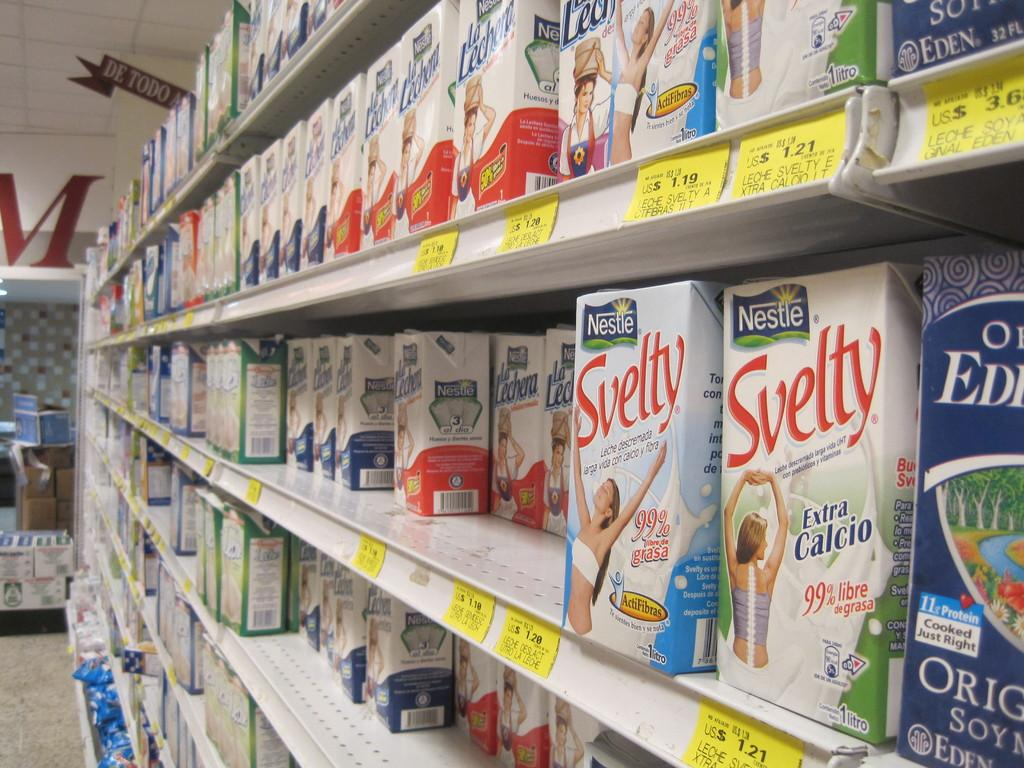<image>
Give a short and clear explanation of the subsequent image. A grocery isle showing different varieties of milk in a carton from Nestle. 